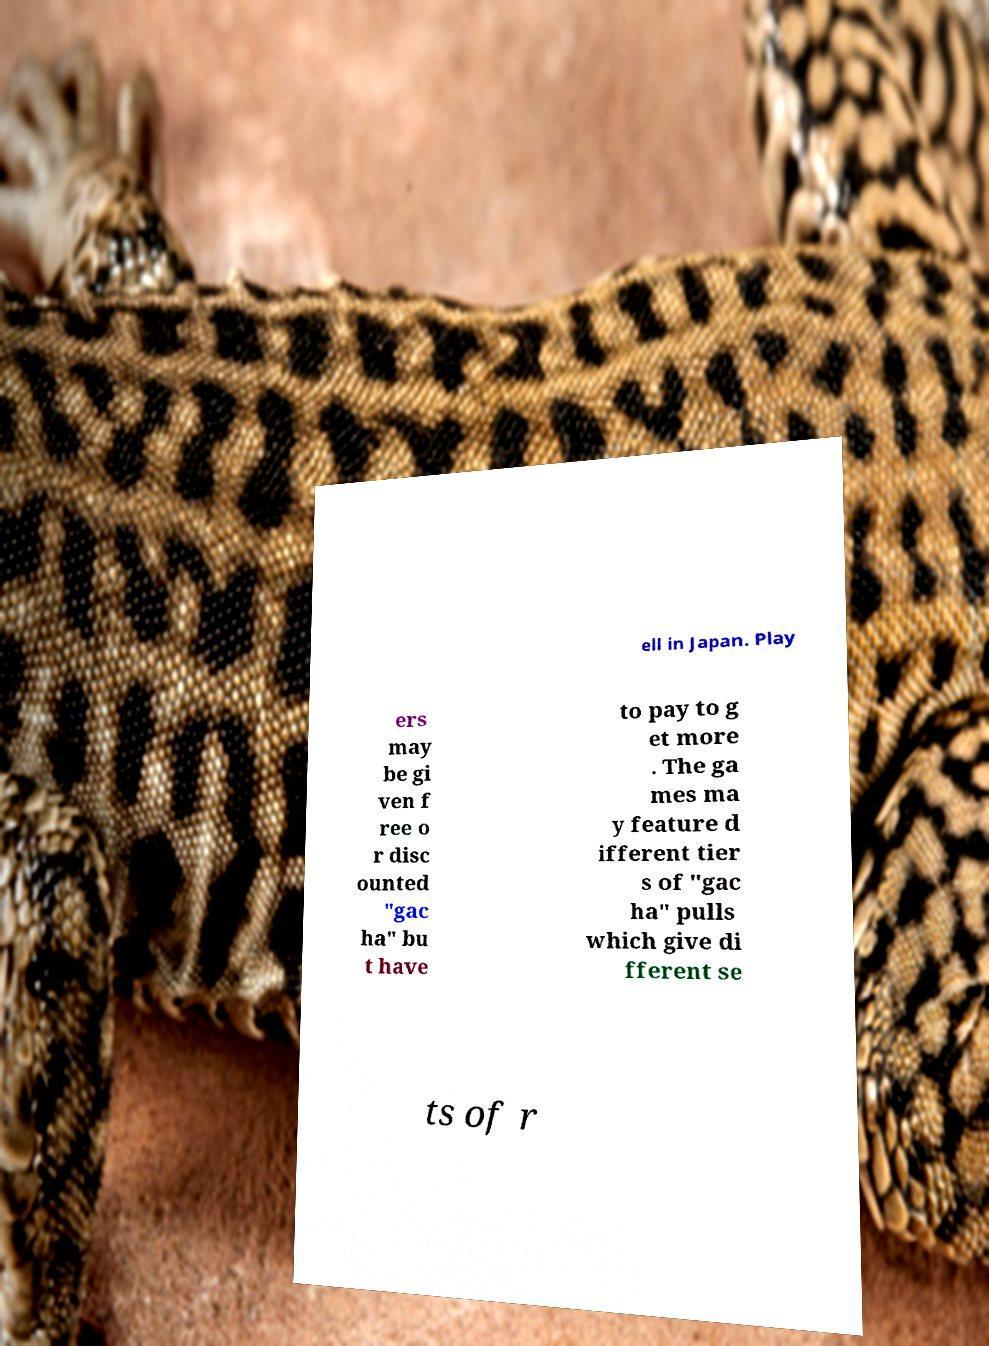Could you extract and type out the text from this image? ell in Japan. Play ers may be gi ven f ree o r disc ounted "gac ha" bu t have to pay to g et more . The ga mes ma y feature d ifferent tier s of "gac ha" pulls which give di fferent se ts of r 